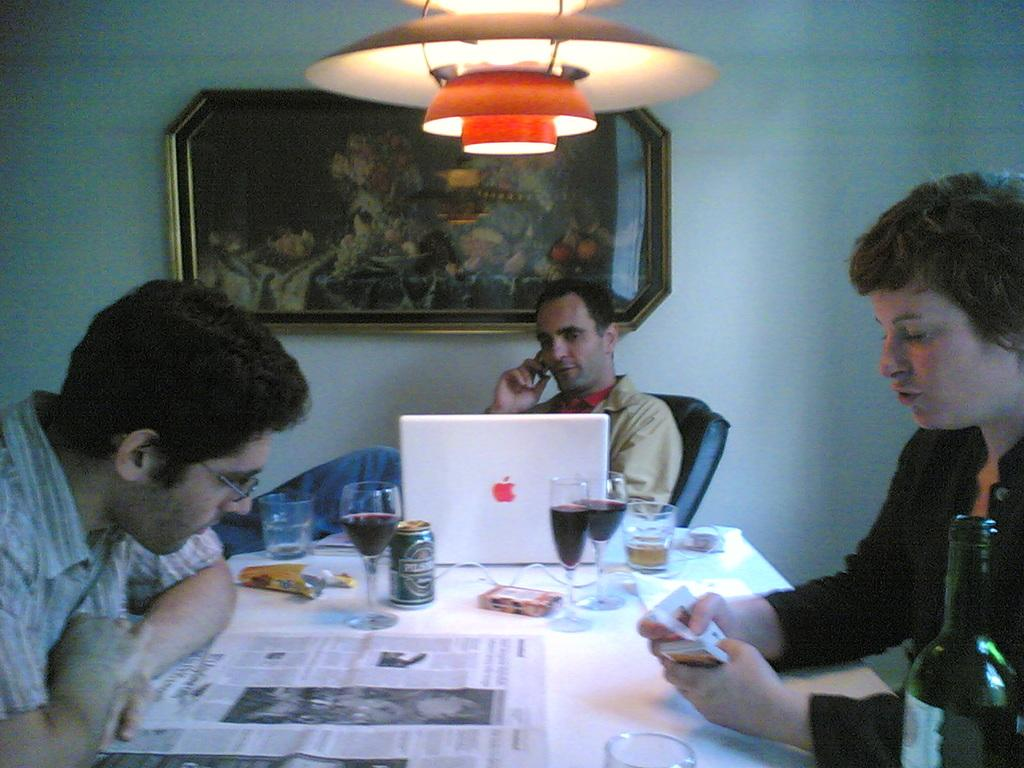What is the main object in the image? There is a frame in the image. What can be seen behind the frame? There is a wall in the image. Is there any source of light in the image? Yes, there is a light in the image. How many people are sitting in the image? There are three people sitting on chairs in the image. What is on the table in the image? There is a laptop and glasses on the table. How many family members are present in the image? The provided facts do not mention any family members, so it is impossible to determine the number of family members present in the image. 